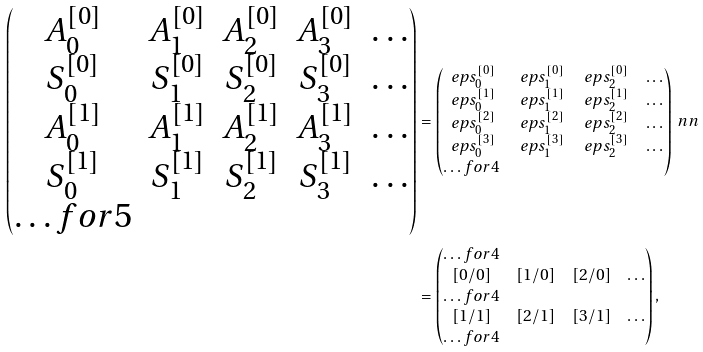Convert formula to latex. <formula><loc_0><loc_0><loc_500><loc_500>\begin{pmatrix} A _ { 0 } ^ { [ 0 ] } & A _ { 1 } ^ { [ 0 ] } & A _ { 2 } ^ { [ 0 ] } & A _ { 3 } ^ { [ 0 ] } & \dots \\ S _ { 0 } ^ { [ 0 ] } & S _ { 1 } ^ { [ 0 ] } & S _ { 2 } ^ { [ 0 ] } & S _ { 3 } ^ { [ 0 ] } & \dots \\ A _ { 0 } ^ { [ 1 ] } & A _ { 1 } ^ { [ 1 ] } & A _ { 2 } ^ { [ 1 ] } & A _ { 3 } ^ { [ 1 ] } & \dots \\ S _ { 0 } ^ { [ 1 ] } & S _ { 1 } ^ { [ 1 ] } & S _ { 2 } ^ { [ 1 ] } & S _ { 3 } ^ { [ 1 ] } & \dots \\ \hdots f o r { 5 } \end{pmatrix} & = \begin{pmatrix} \ e p s _ { 0 } ^ { [ 0 ] } & \ e p s _ { 1 } ^ { [ 0 ] } & \ e p s _ { 2 } ^ { [ 0 ] } & \dots \\ \ e p s _ { 0 } ^ { [ 1 ] } & \ e p s _ { 1 } ^ { [ 1 ] } & \ e p s _ { 2 } ^ { [ 1 ] } & \dots \\ \ e p s _ { 0 } ^ { [ 2 ] } & \ e p s _ { 1 } ^ { [ 2 ] } & \ e p s _ { 2 } ^ { [ 2 ] } & \dots \\ \ e p s _ { 0 } ^ { [ 3 ] } & \ e p s _ { 1 } ^ { [ 3 ] } & \ e p s _ { 2 } ^ { [ 3 ] } & \dots \\ \hdots f o r { 4 } \end{pmatrix} \ n n \\ & = \begin{pmatrix} \hdots f o r { 4 } \\ \left [ 0 / 0 \right ] & [ 1 / 0 ] & [ 2 / 0 ] & \dots \\ \hdots f o r { 4 } \\ \left [ 1 / 1 \right ] & [ 2 / 1 ] & [ 3 / 1 ] & \dots \\ \hdots f o r { 4 } \\ \end{pmatrix} ,</formula> 